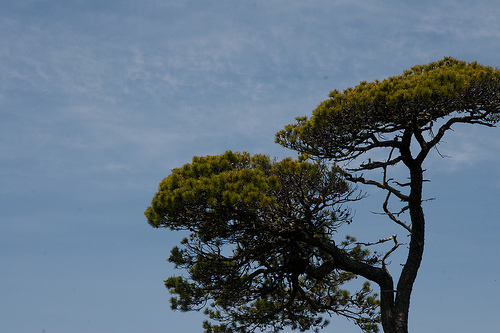<image>
Is the sky to the right of the tree? No. The sky is not to the right of the tree. The horizontal positioning shows a different relationship. 